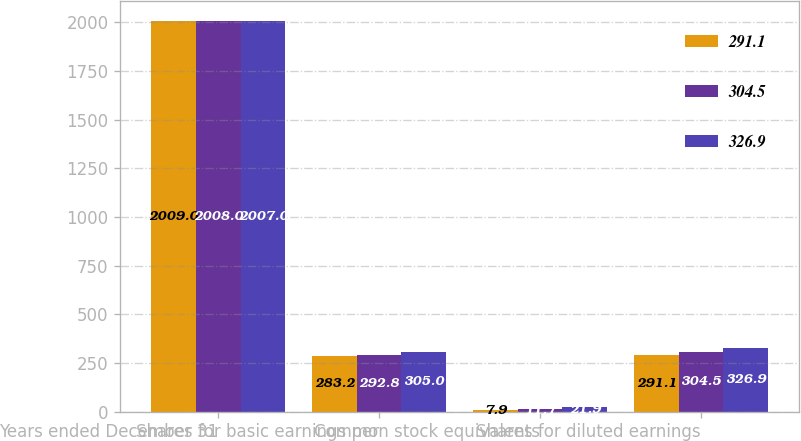<chart> <loc_0><loc_0><loc_500><loc_500><stacked_bar_chart><ecel><fcel>Years ended December 31<fcel>Shares for basic earnings per<fcel>Common stock equivalents<fcel>Shares for diluted earnings<nl><fcel>291.1<fcel>2009<fcel>283.2<fcel>7.9<fcel>291.1<nl><fcel>304.5<fcel>2008<fcel>292.8<fcel>11.7<fcel>304.5<nl><fcel>326.9<fcel>2007<fcel>305<fcel>21.9<fcel>326.9<nl></chart> 